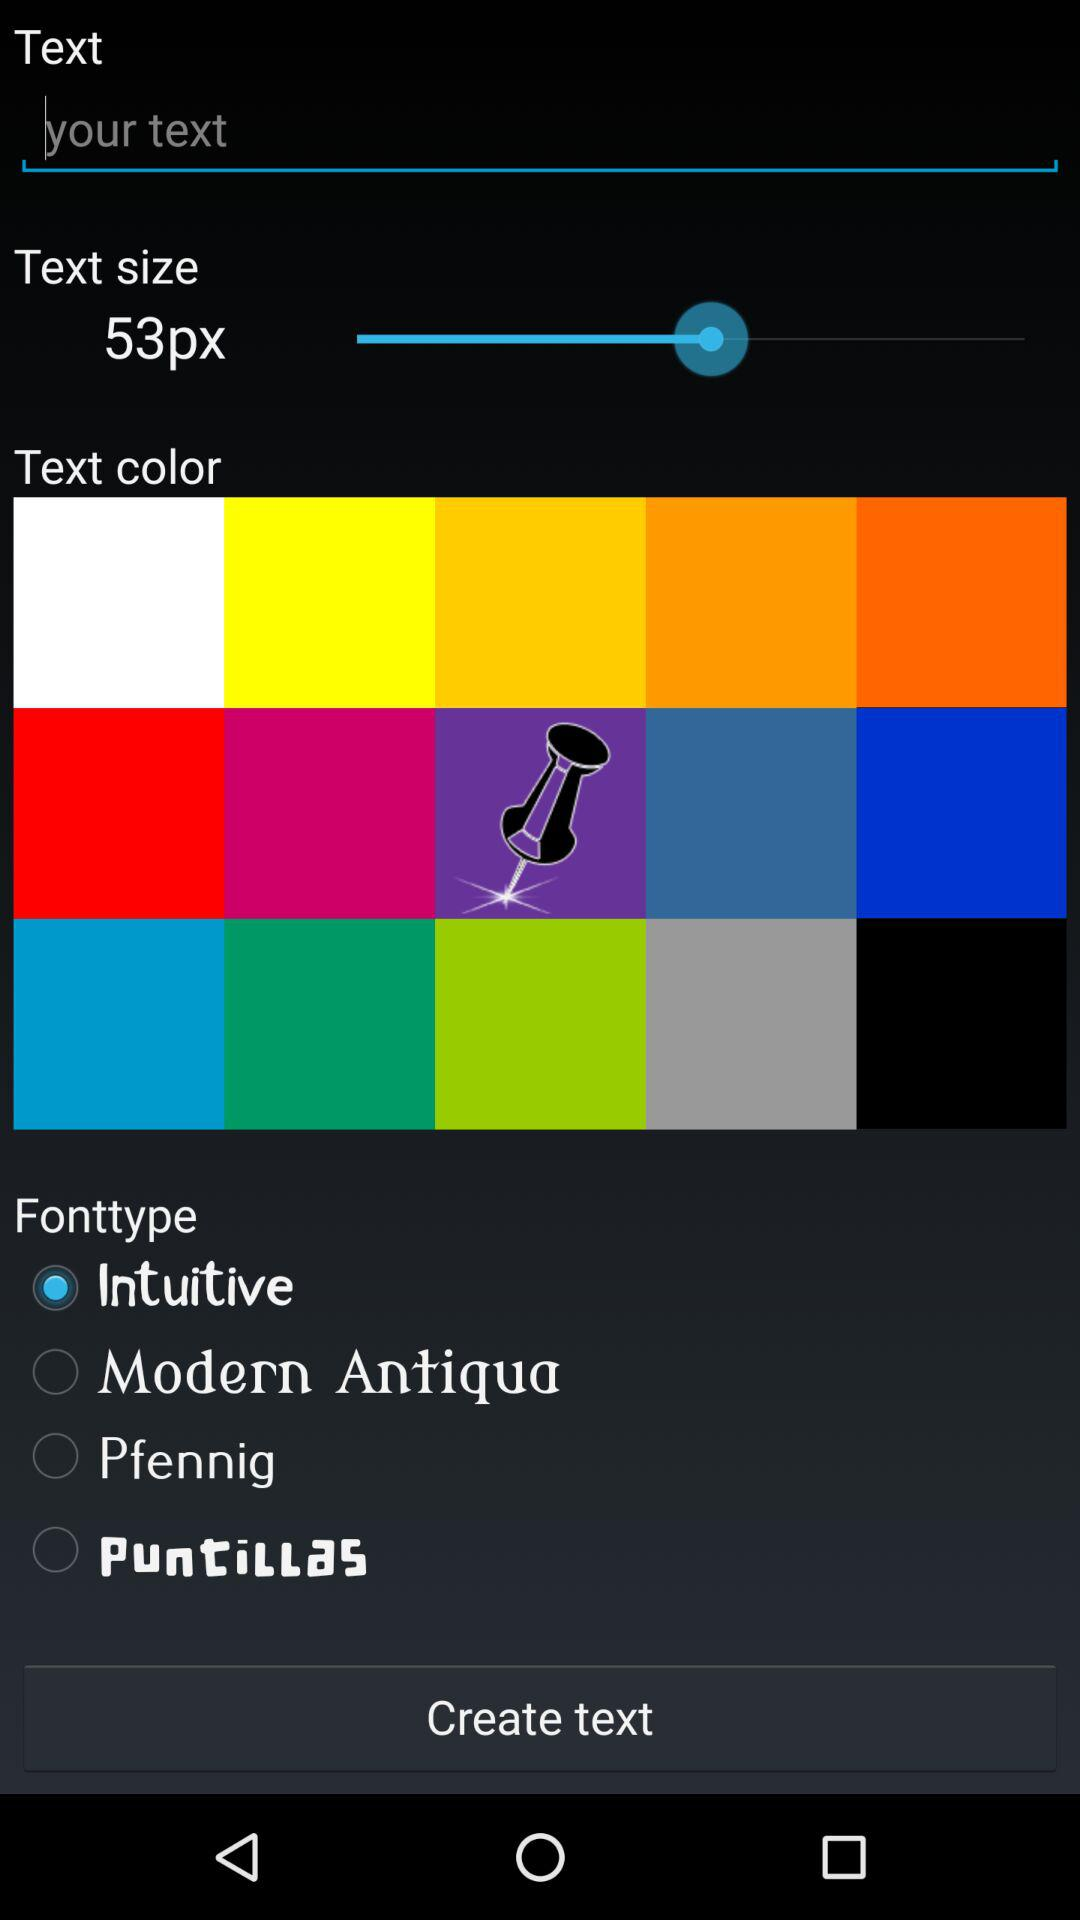Which font type option is selected? The selected option is "Intuitive". 